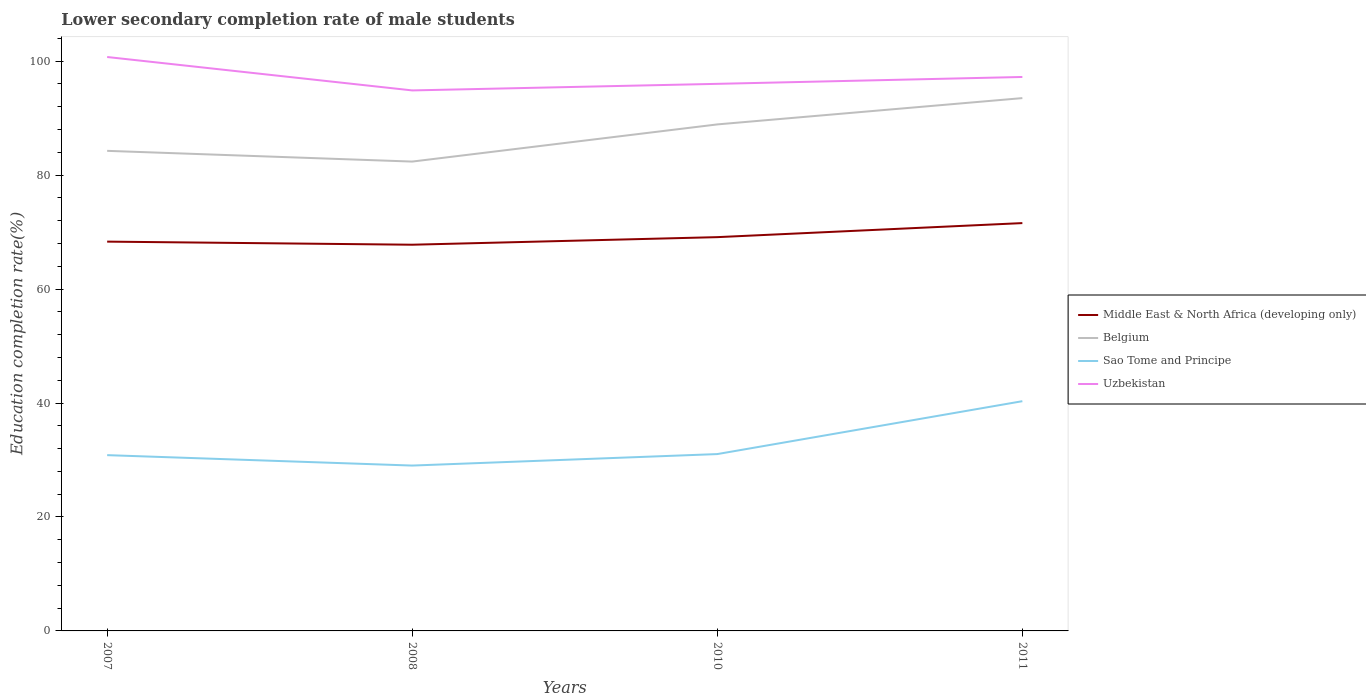How many different coloured lines are there?
Offer a terse response. 4. Does the line corresponding to Uzbekistan intersect with the line corresponding to Belgium?
Provide a succinct answer. No. Across all years, what is the maximum lower secondary completion rate of male students in Belgium?
Provide a succinct answer. 82.38. What is the total lower secondary completion rate of male students in Sao Tome and Principe in the graph?
Offer a terse response. -2.01. What is the difference between the highest and the second highest lower secondary completion rate of male students in Middle East & North Africa (developing only)?
Offer a terse response. 3.79. What is the difference between the highest and the lowest lower secondary completion rate of male students in Belgium?
Your answer should be very brief. 2. Is the lower secondary completion rate of male students in Middle East & North Africa (developing only) strictly greater than the lower secondary completion rate of male students in Sao Tome and Principe over the years?
Your response must be concise. No. How many lines are there?
Provide a succinct answer. 4. How many years are there in the graph?
Offer a terse response. 4. What is the difference between two consecutive major ticks on the Y-axis?
Your response must be concise. 20. Does the graph contain any zero values?
Your answer should be compact. No. Does the graph contain grids?
Offer a very short reply. No. Where does the legend appear in the graph?
Offer a very short reply. Center right. How are the legend labels stacked?
Offer a terse response. Vertical. What is the title of the graph?
Your response must be concise. Lower secondary completion rate of male students. What is the label or title of the Y-axis?
Provide a short and direct response. Education completion rate(%). What is the Education completion rate(%) in Middle East & North Africa (developing only) in 2007?
Your response must be concise. 68.33. What is the Education completion rate(%) in Belgium in 2007?
Your response must be concise. 84.27. What is the Education completion rate(%) in Sao Tome and Principe in 2007?
Your answer should be very brief. 30.85. What is the Education completion rate(%) of Uzbekistan in 2007?
Provide a succinct answer. 100.74. What is the Education completion rate(%) of Middle East & North Africa (developing only) in 2008?
Your response must be concise. 67.79. What is the Education completion rate(%) in Belgium in 2008?
Provide a succinct answer. 82.38. What is the Education completion rate(%) in Sao Tome and Principe in 2008?
Offer a very short reply. 29.03. What is the Education completion rate(%) of Uzbekistan in 2008?
Your response must be concise. 94.87. What is the Education completion rate(%) of Middle East & North Africa (developing only) in 2010?
Make the answer very short. 69.12. What is the Education completion rate(%) of Belgium in 2010?
Keep it short and to the point. 88.91. What is the Education completion rate(%) of Sao Tome and Principe in 2010?
Offer a very short reply. 31.04. What is the Education completion rate(%) in Uzbekistan in 2010?
Give a very brief answer. 96.02. What is the Education completion rate(%) in Middle East & North Africa (developing only) in 2011?
Provide a succinct answer. 71.58. What is the Education completion rate(%) in Belgium in 2011?
Ensure brevity in your answer.  93.52. What is the Education completion rate(%) of Sao Tome and Principe in 2011?
Ensure brevity in your answer.  40.33. What is the Education completion rate(%) of Uzbekistan in 2011?
Make the answer very short. 97.23. Across all years, what is the maximum Education completion rate(%) in Middle East & North Africa (developing only)?
Provide a short and direct response. 71.58. Across all years, what is the maximum Education completion rate(%) in Belgium?
Make the answer very short. 93.52. Across all years, what is the maximum Education completion rate(%) of Sao Tome and Principe?
Offer a very short reply. 40.33. Across all years, what is the maximum Education completion rate(%) of Uzbekistan?
Give a very brief answer. 100.74. Across all years, what is the minimum Education completion rate(%) of Middle East & North Africa (developing only)?
Your answer should be compact. 67.79. Across all years, what is the minimum Education completion rate(%) in Belgium?
Offer a terse response. 82.38. Across all years, what is the minimum Education completion rate(%) in Sao Tome and Principe?
Make the answer very short. 29.03. Across all years, what is the minimum Education completion rate(%) in Uzbekistan?
Your response must be concise. 94.87. What is the total Education completion rate(%) of Middle East & North Africa (developing only) in the graph?
Provide a succinct answer. 276.82. What is the total Education completion rate(%) of Belgium in the graph?
Your answer should be compact. 349.08. What is the total Education completion rate(%) of Sao Tome and Principe in the graph?
Offer a very short reply. 131.24. What is the total Education completion rate(%) in Uzbekistan in the graph?
Provide a succinct answer. 388.87. What is the difference between the Education completion rate(%) in Middle East & North Africa (developing only) in 2007 and that in 2008?
Offer a very short reply. 0.54. What is the difference between the Education completion rate(%) in Belgium in 2007 and that in 2008?
Your response must be concise. 1.88. What is the difference between the Education completion rate(%) in Sao Tome and Principe in 2007 and that in 2008?
Your answer should be compact. 1.83. What is the difference between the Education completion rate(%) in Uzbekistan in 2007 and that in 2008?
Offer a very short reply. 5.87. What is the difference between the Education completion rate(%) of Middle East & North Africa (developing only) in 2007 and that in 2010?
Provide a short and direct response. -0.79. What is the difference between the Education completion rate(%) in Belgium in 2007 and that in 2010?
Provide a short and direct response. -4.64. What is the difference between the Education completion rate(%) in Sao Tome and Principe in 2007 and that in 2010?
Your answer should be compact. -0.19. What is the difference between the Education completion rate(%) in Uzbekistan in 2007 and that in 2010?
Ensure brevity in your answer.  4.71. What is the difference between the Education completion rate(%) of Middle East & North Africa (developing only) in 2007 and that in 2011?
Keep it short and to the point. -3.25. What is the difference between the Education completion rate(%) of Belgium in 2007 and that in 2011?
Provide a succinct answer. -9.26. What is the difference between the Education completion rate(%) in Sao Tome and Principe in 2007 and that in 2011?
Your answer should be compact. -9.47. What is the difference between the Education completion rate(%) in Uzbekistan in 2007 and that in 2011?
Your response must be concise. 3.5. What is the difference between the Education completion rate(%) of Middle East & North Africa (developing only) in 2008 and that in 2010?
Offer a terse response. -1.33. What is the difference between the Education completion rate(%) in Belgium in 2008 and that in 2010?
Provide a succinct answer. -6.52. What is the difference between the Education completion rate(%) of Sao Tome and Principe in 2008 and that in 2010?
Your answer should be compact. -2.01. What is the difference between the Education completion rate(%) in Uzbekistan in 2008 and that in 2010?
Offer a very short reply. -1.15. What is the difference between the Education completion rate(%) in Middle East & North Africa (developing only) in 2008 and that in 2011?
Provide a succinct answer. -3.79. What is the difference between the Education completion rate(%) in Belgium in 2008 and that in 2011?
Offer a terse response. -11.14. What is the difference between the Education completion rate(%) in Sao Tome and Principe in 2008 and that in 2011?
Give a very brief answer. -11.3. What is the difference between the Education completion rate(%) of Uzbekistan in 2008 and that in 2011?
Your response must be concise. -2.36. What is the difference between the Education completion rate(%) of Middle East & North Africa (developing only) in 2010 and that in 2011?
Your answer should be compact. -2.47. What is the difference between the Education completion rate(%) of Belgium in 2010 and that in 2011?
Make the answer very short. -4.62. What is the difference between the Education completion rate(%) of Sao Tome and Principe in 2010 and that in 2011?
Provide a succinct answer. -9.29. What is the difference between the Education completion rate(%) in Uzbekistan in 2010 and that in 2011?
Offer a terse response. -1.21. What is the difference between the Education completion rate(%) in Middle East & North Africa (developing only) in 2007 and the Education completion rate(%) in Belgium in 2008?
Your answer should be very brief. -14.05. What is the difference between the Education completion rate(%) of Middle East & North Africa (developing only) in 2007 and the Education completion rate(%) of Sao Tome and Principe in 2008?
Your answer should be very brief. 39.31. What is the difference between the Education completion rate(%) in Middle East & North Africa (developing only) in 2007 and the Education completion rate(%) in Uzbekistan in 2008?
Provide a short and direct response. -26.54. What is the difference between the Education completion rate(%) in Belgium in 2007 and the Education completion rate(%) in Sao Tome and Principe in 2008?
Your answer should be compact. 55.24. What is the difference between the Education completion rate(%) of Belgium in 2007 and the Education completion rate(%) of Uzbekistan in 2008?
Your answer should be compact. -10.6. What is the difference between the Education completion rate(%) of Sao Tome and Principe in 2007 and the Education completion rate(%) of Uzbekistan in 2008?
Ensure brevity in your answer.  -64.02. What is the difference between the Education completion rate(%) of Middle East & North Africa (developing only) in 2007 and the Education completion rate(%) of Belgium in 2010?
Your answer should be compact. -20.57. What is the difference between the Education completion rate(%) in Middle East & North Africa (developing only) in 2007 and the Education completion rate(%) in Sao Tome and Principe in 2010?
Offer a terse response. 37.29. What is the difference between the Education completion rate(%) in Middle East & North Africa (developing only) in 2007 and the Education completion rate(%) in Uzbekistan in 2010?
Provide a short and direct response. -27.69. What is the difference between the Education completion rate(%) of Belgium in 2007 and the Education completion rate(%) of Sao Tome and Principe in 2010?
Offer a terse response. 53.23. What is the difference between the Education completion rate(%) in Belgium in 2007 and the Education completion rate(%) in Uzbekistan in 2010?
Provide a succinct answer. -11.76. What is the difference between the Education completion rate(%) of Sao Tome and Principe in 2007 and the Education completion rate(%) of Uzbekistan in 2010?
Keep it short and to the point. -65.17. What is the difference between the Education completion rate(%) of Middle East & North Africa (developing only) in 2007 and the Education completion rate(%) of Belgium in 2011?
Keep it short and to the point. -25.19. What is the difference between the Education completion rate(%) of Middle East & North Africa (developing only) in 2007 and the Education completion rate(%) of Sao Tome and Principe in 2011?
Make the answer very short. 28.01. What is the difference between the Education completion rate(%) in Middle East & North Africa (developing only) in 2007 and the Education completion rate(%) in Uzbekistan in 2011?
Your answer should be very brief. -28.9. What is the difference between the Education completion rate(%) of Belgium in 2007 and the Education completion rate(%) of Sao Tome and Principe in 2011?
Provide a short and direct response. 43.94. What is the difference between the Education completion rate(%) in Belgium in 2007 and the Education completion rate(%) in Uzbekistan in 2011?
Offer a very short reply. -12.97. What is the difference between the Education completion rate(%) in Sao Tome and Principe in 2007 and the Education completion rate(%) in Uzbekistan in 2011?
Provide a succinct answer. -66.38. What is the difference between the Education completion rate(%) of Middle East & North Africa (developing only) in 2008 and the Education completion rate(%) of Belgium in 2010?
Give a very brief answer. -21.12. What is the difference between the Education completion rate(%) in Middle East & North Africa (developing only) in 2008 and the Education completion rate(%) in Sao Tome and Principe in 2010?
Your answer should be compact. 36.75. What is the difference between the Education completion rate(%) in Middle East & North Africa (developing only) in 2008 and the Education completion rate(%) in Uzbekistan in 2010?
Offer a very short reply. -28.24. What is the difference between the Education completion rate(%) of Belgium in 2008 and the Education completion rate(%) of Sao Tome and Principe in 2010?
Your answer should be very brief. 51.34. What is the difference between the Education completion rate(%) of Belgium in 2008 and the Education completion rate(%) of Uzbekistan in 2010?
Your response must be concise. -13.64. What is the difference between the Education completion rate(%) of Sao Tome and Principe in 2008 and the Education completion rate(%) of Uzbekistan in 2010?
Provide a short and direct response. -67. What is the difference between the Education completion rate(%) in Middle East & North Africa (developing only) in 2008 and the Education completion rate(%) in Belgium in 2011?
Keep it short and to the point. -25.73. What is the difference between the Education completion rate(%) of Middle East & North Africa (developing only) in 2008 and the Education completion rate(%) of Sao Tome and Principe in 2011?
Provide a short and direct response. 27.46. What is the difference between the Education completion rate(%) of Middle East & North Africa (developing only) in 2008 and the Education completion rate(%) of Uzbekistan in 2011?
Make the answer very short. -29.44. What is the difference between the Education completion rate(%) of Belgium in 2008 and the Education completion rate(%) of Sao Tome and Principe in 2011?
Offer a very short reply. 42.06. What is the difference between the Education completion rate(%) of Belgium in 2008 and the Education completion rate(%) of Uzbekistan in 2011?
Make the answer very short. -14.85. What is the difference between the Education completion rate(%) of Sao Tome and Principe in 2008 and the Education completion rate(%) of Uzbekistan in 2011?
Offer a terse response. -68.21. What is the difference between the Education completion rate(%) of Middle East & North Africa (developing only) in 2010 and the Education completion rate(%) of Belgium in 2011?
Your answer should be compact. -24.41. What is the difference between the Education completion rate(%) of Middle East & North Africa (developing only) in 2010 and the Education completion rate(%) of Sao Tome and Principe in 2011?
Your answer should be very brief. 28.79. What is the difference between the Education completion rate(%) in Middle East & North Africa (developing only) in 2010 and the Education completion rate(%) in Uzbekistan in 2011?
Your answer should be compact. -28.12. What is the difference between the Education completion rate(%) of Belgium in 2010 and the Education completion rate(%) of Sao Tome and Principe in 2011?
Your answer should be very brief. 48.58. What is the difference between the Education completion rate(%) of Belgium in 2010 and the Education completion rate(%) of Uzbekistan in 2011?
Offer a terse response. -8.33. What is the difference between the Education completion rate(%) of Sao Tome and Principe in 2010 and the Education completion rate(%) of Uzbekistan in 2011?
Your answer should be very brief. -66.19. What is the average Education completion rate(%) of Middle East & North Africa (developing only) per year?
Keep it short and to the point. 69.21. What is the average Education completion rate(%) in Belgium per year?
Your response must be concise. 87.27. What is the average Education completion rate(%) in Sao Tome and Principe per year?
Ensure brevity in your answer.  32.81. What is the average Education completion rate(%) in Uzbekistan per year?
Provide a short and direct response. 97.22. In the year 2007, what is the difference between the Education completion rate(%) in Middle East & North Africa (developing only) and Education completion rate(%) in Belgium?
Offer a terse response. -15.94. In the year 2007, what is the difference between the Education completion rate(%) of Middle East & North Africa (developing only) and Education completion rate(%) of Sao Tome and Principe?
Offer a very short reply. 37.48. In the year 2007, what is the difference between the Education completion rate(%) in Middle East & North Africa (developing only) and Education completion rate(%) in Uzbekistan?
Your answer should be very brief. -32.41. In the year 2007, what is the difference between the Education completion rate(%) in Belgium and Education completion rate(%) in Sao Tome and Principe?
Give a very brief answer. 53.41. In the year 2007, what is the difference between the Education completion rate(%) of Belgium and Education completion rate(%) of Uzbekistan?
Ensure brevity in your answer.  -16.47. In the year 2007, what is the difference between the Education completion rate(%) of Sao Tome and Principe and Education completion rate(%) of Uzbekistan?
Offer a very short reply. -69.88. In the year 2008, what is the difference between the Education completion rate(%) in Middle East & North Africa (developing only) and Education completion rate(%) in Belgium?
Provide a succinct answer. -14.59. In the year 2008, what is the difference between the Education completion rate(%) of Middle East & North Africa (developing only) and Education completion rate(%) of Sao Tome and Principe?
Make the answer very short. 38.76. In the year 2008, what is the difference between the Education completion rate(%) in Middle East & North Africa (developing only) and Education completion rate(%) in Uzbekistan?
Ensure brevity in your answer.  -27.08. In the year 2008, what is the difference between the Education completion rate(%) of Belgium and Education completion rate(%) of Sao Tome and Principe?
Keep it short and to the point. 53.36. In the year 2008, what is the difference between the Education completion rate(%) of Belgium and Education completion rate(%) of Uzbekistan?
Your answer should be very brief. -12.49. In the year 2008, what is the difference between the Education completion rate(%) of Sao Tome and Principe and Education completion rate(%) of Uzbekistan?
Provide a succinct answer. -65.85. In the year 2010, what is the difference between the Education completion rate(%) in Middle East & North Africa (developing only) and Education completion rate(%) in Belgium?
Provide a short and direct response. -19.79. In the year 2010, what is the difference between the Education completion rate(%) in Middle East & North Africa (developing only) and Education completion rate(%) in Sao Tome and Principe?
Provide a short and direct response. 38.08. In the year 2010, what is the difference between the Education completion rate(%) of Middle East & North Africa (developing only) and Education completion rate(%) of Uzbekistan?
Provide a succinct answer. -26.91. In the year 2010, what is the difference between the Education completion rate(%) in Belgium and Education completion rate(%) in Sao Tome and Principe?
Provide a short and direct response. 57.87. In the year 2010, what is the difference between the Education completion rate(%) of Belgium and Education completion rate(%) of Uzbekistan?
Provide a short and direct response. -7.12. In the year 2010, what is the difference between the Education completion rate(%) in Sao Tome and Principe and Education completion rate(%) in Uzbekistan?
Your response must be concise. -64.98. In the year 2011, what is the difference between the Education completion rate(%) of Middle East & North Africa (developing only) and Education completion rate(%) of Belgium?
Keep it short and to the point. -21.94. In the year 2011, what is the difference between the Education completion rate(%) of Middle East & North Africa (developing only) and Education completion rate(%) of Sao Tome and Principe?
Make the answer very short. 31.26. In the year 2011, what is the difference between the Education completion rate(%) of Middle East & North Africa (developing only) and Education completion rate(%) of Uzbekistan?
Ensure brevity in your answer.  -25.65. In the year 2011, what is the difference between the Education completion rate(%) in Belgium and Education completion rate(%) in Sao Tome and Principe?
Give a very brief answer. 53.2. In the year 2011, what is the difference between the Education completion rate(%) in Belgium and Education completion rate(%) in Uzbekistan?
Offer a very short reply. -3.71. In the year 2011, what is the difference between the Education completion rate(%) of Sao Tome and Principe and Education completion rate(%) of Uzbekistan?
Provide a short and direct response. -56.91. What is the ratio of the Education completion rate(%) of Belgium in 2007 to that in 2008?
Give a very brief answer. 1.02. What is the ratio of the Education completion rate(%) in Sao Tome and Principe in 2007 to that in 2008?
Ensure brevity in your answer.  1.06. What is the ratio of the Education completion rate(%) in Uzbekistan in 2007 to that in 2008?
Give a very brief answer. 1.06. What is the ratio of the Education completion rate(%) of Middle East & North Africa (developing only) in 2007 to that in 2010?
Keep it short and to the point. 0.99. What is the ratio of the Education completion rate(%) of Belgium in 2007 to that in 2010?
Ensure brevity in your answer.  0.95. What is the ratio of the Education completion rate(%) of Sao Tome and Principe in 2007 to that in 2010?
Keep it short and to the point. 0.99. What is the ratio of the Education completion rate(%) in Uzbekistan in 2007 to that in 2010?
Give a very brief answer. 1.05. What is the ratio of the Education completion rate(%) in Middle East & North Africa (developing only) in 2007 to that in 2011?
Provide a short and direct response. 0.95. What is the ratio of the Education completion rate(%) in Belgium in 2007 to that in 2011?
Keep it short and to the point. 0.9. What is the ratio of the Education completion rate(%) of Sao Tome and Principe in 2007 to that in 2011?
Keep it short and to the point. 0.77. What is the ratio of the Education completion rate(%) in Uzbekistan in 2007 to that in 2011?
Your response must be concise. 1.04. What is the ratio of the Education completion rate(%) of Middle East & North Africa (developing only) in 2008 to that in 2010?
Your answer should be compact. 0.98. What is the ratio of the Education completion rate(%) in Belgium in 2008 to that in 2010?
Provide a succinct answer. 0.93. What is the ratio of the Education completion rate(%) in Sao Tome and Principe in 2008 to that in 2010?
Keep it short and to the point. 0.94. What is the ratio of the Education completion rate(%) in Uzbekistan in 2008 to that in 2010?
Offer a terse response. 0.99. What is the ratio of the Education completion rate(%) in Middle East & North Africa (developing only) in 2008 to that in 2011?
Offer a terse response. 0.95. What is the ratio of the Education completion rate(%) in Belgium in 2008 to that in 2011?
Your response must be concise. 0.88. What is the ratio of the Education completion rate(%) in Sao Tome and Principe in 2008 to that in 2011?
Provide a short and direct response. 0.72. What is the ratio of the Education completion rate(%) of Uzbekistan in 2008 to that in 2011?
Give a very brief answer. 0.98. What is the ratio of the Education completion rate(%) in Middle East & North Africa (developing only) in 2010 to that in 2011?
Provide a succinct answer. 0.97. What is the ratio of the Education completion rate(%) in Belgium in 2010 to that in 2011?
Provide a short and direct response. 0.95. What is the ratio of the Education completion rate(%) in Sao Tome and Principe in 2010 to that in 2011?
Offer a very short reply. 0.77. What is the ratio of the Education completion rate(%) in Uzbekistan in 2010 to that in 2011?
Make the answer very short. 0.99. What is the difference between the highest and the second highest Education completion rate(%) in Middle East & North Africa (developing only)?
Offer a very short reply. 2.47. What is the difference between the highest and the second highest Education completion rate(%) in Belgium?
Your answer should be compact. 4.62. What is the difference between the highest and the second highest Education completion rate(%) in Sao Tome and Principe?
Provide a succinct answer. 9.29. What is the difference between the highest and the second highest Education completion rate(%) in Uzbekistan?
Make the answer very short. 3.5. What is the difference between the highest and the lowest Education completion rate(%) of Middle East & North Africa (developing only)?
Give a very brief answer. 3.79. What is the difference between the highest and the lowest Education completion rate(%) in Belgium?
Offer a terse response. 11.14. What is the difference between the highest and the lowest Education completion rate(%) in Sao Tome and Principe?
Keep it short and to the point. 11.3. What is the difference between the highest and the lowest Education completion rate(%) of Uzbekistan?
Keep it short and to the point. 5.87. 